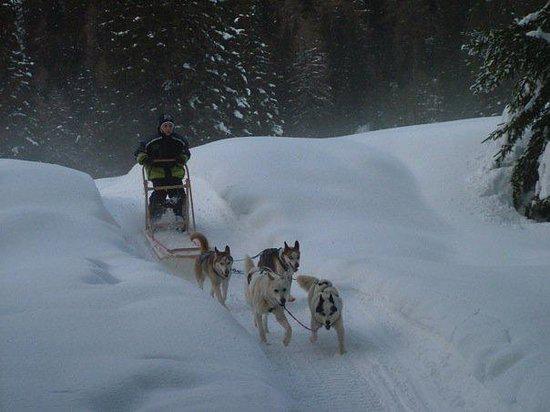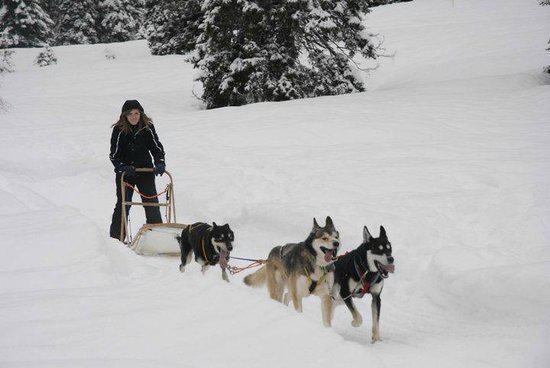The first image is the image on the left, the second image is the image on the right. For the images shown, is this caption "The sled teams in the two images are headed in the same direction." true? Answer yes or no. Yes. The first image is the image on the left, the second image is the image on the right. Assess this claim about the two images: "There are exactly three dogs pulling the sled in the image on the right". Correct or not? Answer yes or no. Yes. 